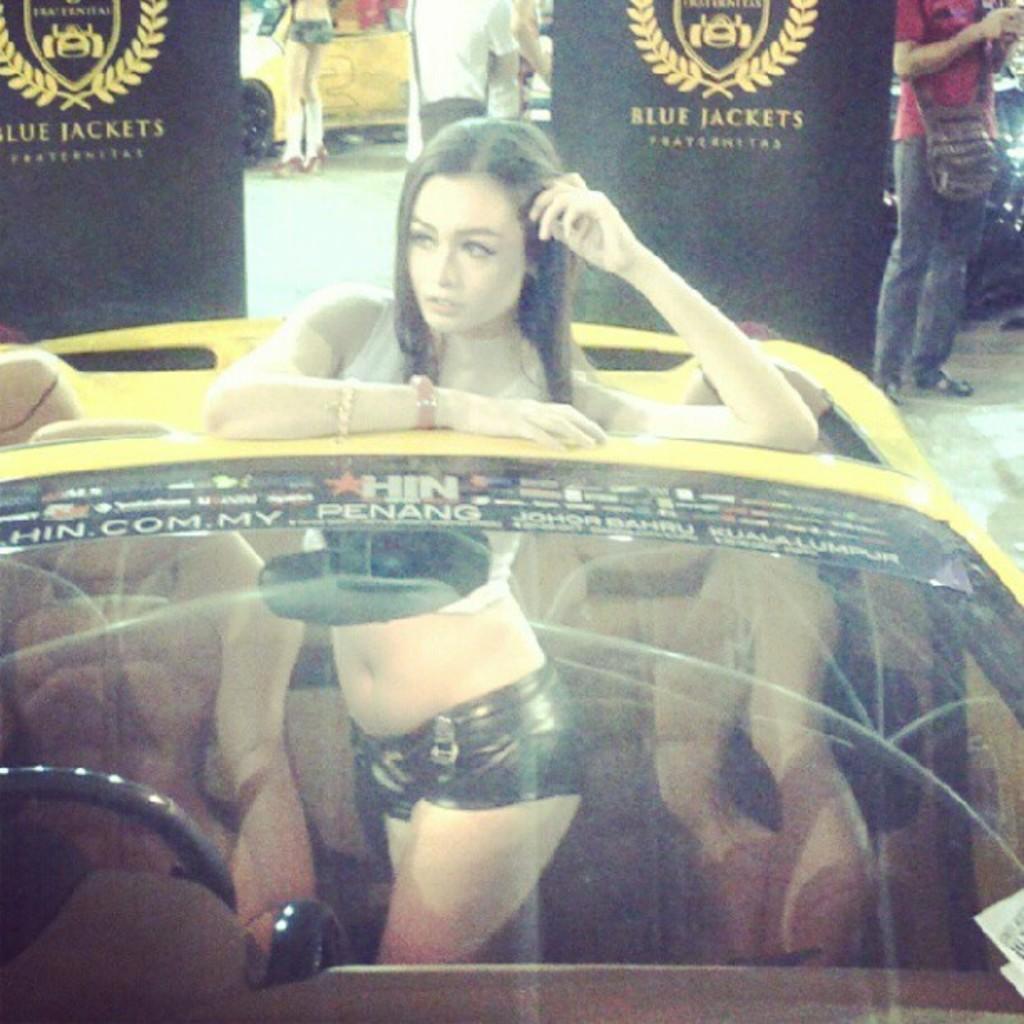Please provide a concise description of this image. This is the picture in the outdoor, there is a woman is standing in a car which is in yellow color. Background of the car is a there are the banner and a man is standing on the floor. 